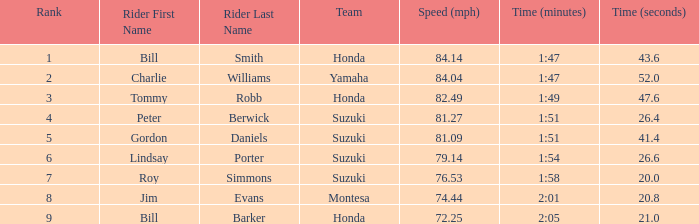Which rider had a time of 1:54.26.6? Lindsay Porter. 